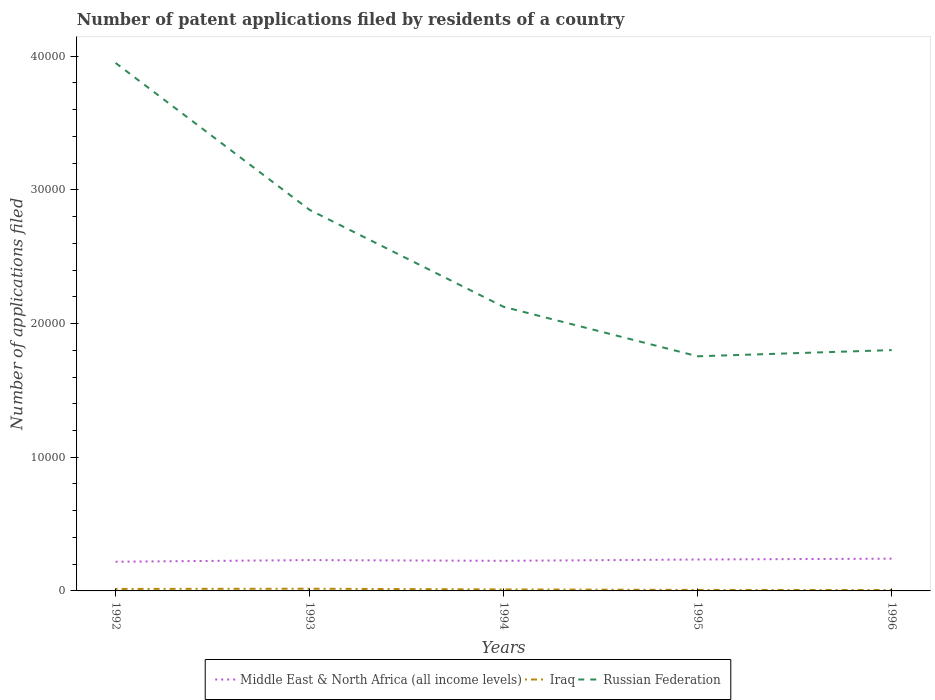How many different coloured lines are there?
Provide a succinct answer. 3. Does the line corresponding to Russian Federation intersect with the line corresponding to Middle East & North Africa (all income levels)?
Provide a short and direct response. No. Is the number of lines equal to the number of legend labels?
Your response must be concise. Yes. Across all years, what is the maximum number of applications filed in Russian Federation?
Offer a terse response. 1.76e+04. In which year was the number of applications filed in Russian Federation maximum?
Provide a short and direct response. 1995. What is the total number of applications filed in Russian Federation in the graph?
Provide a short and direct response. 1.82e+04. What is the difference between the highest and the second highest number of applications filed in Middle East & North Africa (all income levels)?
Keep it short and to the point. 230. Is the number of applications filed in Russian Federation strictly greater than the number of applications filed in Middle East & North Africa (all income levels) over the years?
Keep it short and to the point. No. Are the values on the major ticks of Y-axis written in scientific E-notation?
Provide a short and direct response. No. Does the graph contain grids?
Your response must be concise. No. What is the title of the graph?
Provide a succinct answer. Number of patent applications filed by residents of a country. Does "Bhutan" appear as one of the legend labels in the graph?
Your answer should be compact. No. What is the label or title of the X-axis?
Provide a succinct answer. Years. What is the label or title of the Y-axis?
Ensure brevity in your answer.  Number of applications filed. What is the Number of applications filed of Middle East & North Africa (all income levels) in 1992?
Keep it short and to the point. 2184. What is the Number of applications filed in Iraq in 1992?
Your response must be concise. 149. What is the Number of applications filed in Russian Federation in 1992?
Provide a short and direct response. 3.95e+04. What is the Number of applications filed of Middle East & North Africa (all income levels) in 1993?
Offer a very short reply. 2306. What is the Number of applications filed in Iraq in 1993?
Offer a terse response. 164. What is the Number of applications filed in Russian Federation in 1993?
Offer a very short reply. 2.85e+04. What is the Number of applications filed of Middle East & North Africa (all income levels) in 1994?
Your response must be concise. 2251. What is the Number of applications filed of Iraq in 1994?
Provide a short and direct response. 112. What is the Number of applications filed in Russian Federation in 1994?
Give a very brief answer. 2.12e+04. What is the Number of applications filed in Middle East & North Africa (all income levels) in 1995?
Your response must be concise. 2350. What is the Number of applications filed of Russian Federation in 1995?
Make the answer very short. 1.76e+04. What is the Number of applications filed of Middle East & North Africa (all income levels) in 1996?
Your answer should be very brief. 2414. What is the Number of applications filed in Russian Federation in 1996?
Offer a very short reply. 1.80e+04. Across all years, what is the maximum Number of applications filed of Middle East & North Africa (all income levels)?
Your answer should be compact. 2414. Across all years, what is the maximum Number of applications filed of Iraq?
Give a very brief answer. 164. Across all years, what is the maximum Number of applications filed of Russian Federation?
Keep it short and to the point. 3.95e+04. Across all years, what is the minimum Number of applications filed in Middle East & North Africa (all income levels)?
Make the answer very short. 2184. Across all years, what is the minimum Number of applications filed of Iraq?
Make the answer very short. 68. Across all years, what is the minimum Number of applications filed in Russian Federation?
Offer a terse response. 1.76e+04. What is the total Number of applications filed in Middle East & North Africa (all income levels) in the graph?
Offer a terse response. 1.15e+04. What is the total Number of applications filed in Iraq in the graph?
Your response must be concise. 569. What is the total Number of applications filed in Russian Federation in the graph?
Your answer should be compact. 1.25e+05. What is the difference between the Number of applications filed in Middle East & North Africa (all income levels) in 1992 and that in 1993?
Make the answer very short. -122. What is the difference between the Number of applications filed in Iraq in 1992 and that in 1993?
Your answer should be compact. -15. What is the difference between the Number of applications filed in Russian Federation in 1992 and that in 1993?
Your answer should be very brief. 1.10e+04. What is the difference between the Number of applications filed in Middle East & North Africa (all income levels) in 1992 and that in 1994?
Provide a succinct answer. -67. What is the difference between the Number of applications filed of Iraq in 1992 and that in 1994?
Your answer should be compact. 37. What is the difference between the Number of applications filed of Russian Federation in 1992 and that in 1994?
Your answer should be very brief. 1.82e+04. What is the difference between the Number of applications filed in Middle East & North Africa (all income levels) in 1992 and that in 1995?
Provide a succinct answer. -166. What is the difference between the Number of applications filed of Russian Federation in 1992 and that in 1995?
Offer a terse response. 2.19e+04. What is the difference between the Number of applications filed of Middle East & North Africa (all income levels) in 1992 and that in 1996?
Provide a succinct answer. -230. What is the difference between the Number of applications filed of Russian Federation in 1992 and that in 1996?
Provide a succinct answer. 2.15e+04. What is the difference between the Number of applications filed of Russian Federation in 1993 and that in 1994?
Give a very brief answer. 7253. What is the difference between the Number of applications filed of Middle East & North Africa (all income levels) in 1993 and that in 1995?
Keep it short and to the point. -44. What is the difference between the Number of applications filed in Iraq in 1993 and that in 1995?
Ensure brevity in your answer.  88. What is the difference between the Number of applications filed of Russian Federation in 1993 and that in 1995?
Your answer should be very brief. 1.10e+04. What is the difference between the Number of applications filed of Middle East & North Africa (all income levels) in 1993 and that in 1996?
Offer a terse response. -108. What is the difference between the Number of applications filed of Iraq in 1993 and that in 1996?
Provide a succinct answer. 96. What is the difference between the Number of applications filed of Russian Federation in 1993 and that in 1996?
Keep it short and to the point. 1.05e+04. What is the difference between the Number of applications filed of Middle East & North Africa (all income levels) in 1994 and that in 1995?
Provide a succinct answer. -99. What is the difference between the Number of applications filed in Iraq in 1994 and that in 1995?
Your answer should be very brief. 36. What is the difference between the Number of applications filed in Russian Federation in 1994 and that in 1995?
Your answer should be compact. 3699. What is the difference between the Number of applications filed of Middle East & North Africa (all income levels) in 1994 and that in 1996?
Ensure brevity in your answer.  -163. What is the difference between the Number of applications filed of Russian Federation in 1994 and that in 1996?
Offer a very short reply. 3236. What is the difference between the Number of applications filed of Middle East & North Africa (all income levels) in 1995 and that in 1996?
Make the answer very short. -64. What is the difference between the Number of applications filed of Iraq in 1995 and that in 1996?
Ensure brevity in your answer.  8. What is the difference between the Number of applications filed of Russian Federation in 1995 and that in 1996?
Make the answer very short. -463. What is the difference between the Number of applications filed in Middle East & North Africa (all income levels) in 1992 and the Number of applications filed in Iraq in 1993?
Provide a short and direct response. 2020. What is the difference between the Number of applications filed of Middle East & North Africa (all income levels) in 1992 and the Number of applications filed of Russian Federation in 1993?
Offer a terse response. -2.63e+04. What is the difference between the Number of applications filed in Iraq in 1992 and the Number of applications filed in Russian Federation in 1993?
Provide a short and direct response. -2.84e+04. What is the difference between the Number of applications filed in Middle East & North Africa (all income levels) in 1992 and the Number of applications filed in Iraq in 1994?
Offer a very short reply. 2072. What is the difference between the Number of applications filed in Middle East & North Africa (all income levels) in 1992 and the Number of applications filed in Russian Federation in 1994?
Your answer should be compact. -1.91e+04. What is the difference between the Number of applications filed of Iraq in 1992 and the Number of applications filed of Russian Federation in 1994?
Provide a succinct answer. -2.11e+04. What is the difference between the Number of applications filed of Middle East & North Africa (all income levels) in 1992 and the Number of applications filed of Iraq in 1995?
Your answer should be very brief. 2108. What is the difference between the Number of applications filed in Middle East & North Africa (all income levels) in 1992 and the Number of applications filed in Russian Federation in 1995?
Provide a short and direct response. -1.54e+04. What is the difference between the Number of applications filed of Iraq in 1992 and the Number of applications filed of Russian Federation in 1995?
Keep it short and to the point. -1.74e+04. What is the difference between the Number of applications filed in Middle East & North Africa (all income levels) in 1992 and the Number of applications filed in Iraq in 1996?
Your answer should be very brief. 2116. What is the difference between the Number of applications filed in Middle East & North Africa (all income levels) in 1992 and the Number of applications filed in Russian Federation in 1996?
Make the answer very short. -1.58e+04. What is the difference between the Number of applications filed of Iraq in 1992 and the Number of applications filed of Russian Federation in 1996?
Provide a short and direct response. -1.79e+04. What is the difference between the Number of applications filed of Middle East & North Africa (all income levels) in 1993 and the Number of applications filed of Iraq in 1994?
Ensure brevity in your answer.  2194. What is the difference between the Number of applications filed of Middle East & North Africa (all income levels) in 1993 and the Number of applications filed of Russian Federation in 1994?
Make the answer very short. -1.89e+04. What is the difference between the Number of applications filed of Iraq in 1993 and the Number of applications filed of Russian Federation in 1994?
Provide a short and direct response. -2.11e+04. What is the difference between the Number of applications filed in Middle East & North Africa (all income levels) in 1993 and the Number of applications filed in Iraq in 1995?
Make the answer very short. 2230. What is the difference between the Number of applications filed of Middle East & North Africa (all income levels) in 1993 and the Number of applications filed of Russian Federation in 1995?
Make the answer very short. -1.52e+04. What is the difference between the Number of applications filed in Iraq in 1993 and the Number of applications filed in Russian Federation in 1995?
Offer a terse response. -1.74e+04. What is the difference between the Number of applications filed of Middle East & North Africa (all income levels) in 1993 and the Number of applications filed of Iraq in 1996?
Offer a terse response. 2238. What is the difference between the Number of applications filed in Middle East & North Africa (all income levels) in 1993 and the Number of applications filed in Russian Federation in 1996?
Offer a very short reply. -1.57e+04. What is the difference between the Number of applications filed in Iraq in 1993 and the Number of applications filed in Russian Federation in 1996?
Provide a succinct answer. -1.78e+04. What is the difference between the Number of applications filed of Middle East & North Africa (all income levels) in 1994 and the Number of applications filed of Iraq in 1995?
Your response must be concise. 2175. What is the difference between the Number of applications filed of Middle East & North Africa (all income levels) in 1994 and the Number of applications filed of Russian Federation in 1995?
Offer a very short reply. -1.53e+04. What is the difference between the Number of applications filed of Iraq in 1994 and the Number of applications filed of Russian Federation in 1995?
Keep it short and to the point. -1.74e+04. What is the difference between the Number of applications filed in Middle East & North Africa (all income levels) in 1994 and the Number of applications filed in Iraq in 1996?
Ensure brevity in your answer.  2183. What is the difference between the Number of applications filed in Middle East & North Africa (all income levels) in 1994 and the Number of applications filed in Russian Federation in 1996?
Provide a succinct answer. -1.58e+04. What is the difference between the Number of applications filed in Iraq in 1994 and the Number of applications filed in Russian Federation in 1996?
Your response must be concise. -1.79e+04. What is the difference between the Number of applications filed of Middle East & North Africa (all income levels) in 1995 and the Number of applications filed of Iraq in 1996?
Provide a short and direct response. 2282. What is the difference between the Number of applications filed in Middle East & North Africa (all income levels) in 1995 and the Number of applications filed in Russian Federation in 1996?
Ensure brevity in your answer.  -1.57e+04. What is the difference between the Number of applications filed of Iraq in 1995 and the Number of applications filed of Russian Federation in 1996?
Offer a very short reply. -1.79e+04. What is the average Number of applications filed in Middle East & North Africa (all income levels) per year?
Provide a succinct answer. 2301. What is the average Number of applications filed in Iraq per year?
Your answer should be compact. 113.8. What is the average Number of applications filed of Russian Federation per year?
Make the answer very short. 2.50e+04. In the year 1992, what is the difference between the Number of applications filed in Middle East & North Africa (all income levels) and Number of applications filed in Iraq?
Give a very brief answer. 2035. In the year 1992, what is the difference between the Number of applications filed of Middle East & North Africa (all income levels) and Number of applications filed of Russian Federation?
Your answer should be compact. -3.73e+04. In the year 1992, what is the difference between the Number of applications filed of Iraq and Number of applications filed of Russian Federation?
Your answer should be compact. -3.93e+04. In the year 1993, what is the difference between the Number of applications filed of Middle East & North Africa (all income levels) and Number of applications filed of Iraq?
Give a very brief answer. 2142. In the year 1993, what is the difference between the Number of applications filed in Middle East & North Africa (all income levels) and Number of applications filed in Russian Federation?
Provide a succinct answer. -2.62e+04. In the year 1993, what is the difference between the Number of applications filed of Iraq and Number of applications filed of Russian Federation?
Your answer should be very brief. -2.83e+04. In the year 1994, what is the difference between the Number of applications filed of Middle East & North Africa (all income levels) and Number of applications filed of Iraq?
Your answer should be very brief. 2139. In the year 1994, what is the difference between the Number of applications filed of Middle East & North Africa (all income levels) and Number of applications filed of Russian Federation?
Make the answer very short. -1.90e+04. In the year 1994, what is the difference between the Number of applications filed of Iraq and Number of applications filed of Russian Federation?
Provide a short and direct response. -2.11e+04. In the year 1995, what is the difference between the Number of applications filed of Middle East & North Africa (all income levels) and Number of applications filed of Iraq?
Give a very brief answer. 2274. In the year 1995, what is the difference between the Number of applications filed of Middle East & North Africa (all income levels) and Number of applications filed of Russian Federation?
Offer a terse response. -1.52e+04. In the year 1995, what is the difference between the Number of applications filed in Iraq and Number of applications filed in Russian Federation?
Provide a succinct answer. -1.75e+04. In the year 1996, what is the difference between the Number of applications filed of Middle East & North Africa (all income levels) and Number of applications filed of Iraq?
Give a very brief answer. 2346. In the year 1996, what is the difference between the Number of applications filed in Middle East & North Africa (all income levels) and Number of applications filed in Russian Federation?
Your response must be concise. -1.56e+04. In the year 1996, what is the difference between the Number of applications filed in Iraq and Number of applications filed in Russian Federation?
Ensure brevity in your answer.  -1.79e+04. What is the ratio of the Number of applications filed of Middle East & North Africa (all income levels) in 1992 to that in 1993?
Offer a very short reply. 0.95. What is the ratio of the Number of applications filed in Iraq in 1992 to that in 1993?
Provide a short and direct response. 0.91. What is the ratio of the Number of applications filed in Russian Federation in 1992 to that in 1993?
Provide a short and direct response. 1.39. What is the ratio of the Number of applications filed of Middle East & North Africa (all income levels) in 1992 to that in 1994?
Offer a very short reply. 0.97. What is the ratio of the Number of applications filed in Iraq in 1992 to that in 1994?
Offer a terse response. 1.33. What is the ratio of the Number of applications filed of Russian Federation in 1992 to that in 1994?
Keep it short and to the point. 1.86. What is the ratio of the Number of applications filed in Middle East & North Africa (all income levels) in 1992 to that in 1995?
Provide a succinct answer. 0.93. What is the ratio of the Number of applications filed in Iraq in 1992 to that in 1995?
Offer a terse response. 1.96. What is the ratio of the Number of applications filed in Russian Federation in 1992 to that in 1995?
Offer a terse response. 2.25. What is the ratio of the Number of applications filed in Middle East & North Africa (all income levels) in 1992 to that in 1996?
Provide a succinct answer. 0.9. What is the ratio of the Number of applications filed of Iraq in 1992 to that in 1996?
Provide a short and direct response. 2.19. What is the ratio of the Number of applications filed of Russian Federation in 1992 to that in 1996?
Make the answer very short. 2.19. What is the ratio of the Number of applications filed in Middle East & North Africa (all income levels) in 1993 to that in 1994?
Ensure brevity in your answer.  1.02. What is the ratio of the Number of applications filed of Iraq in 1993 to that in 1994?
Offer a terse response. 1.46. What is the ratio of the Number of applications filed of Russian Federation in 1993 to that in 1994?
Your response must be concise. 1.34. What is the ratio of the Number of applications filed in Middle East & North Africa (all income levels) in 1993 to that in 1995?
Your response must be concise. 0.98. What is the ratio of the Number of applications filed of Iraq in 1993 to that in 1995?
Provide a succinct answer. 2.16. What is the ratio of the Number of applications filed in Russian Federation in 1993 to that in 1995?
Give a very brief answer. 1.62. What is the ratio of the Number of applications filed of Middle East & North Africa (all income levels) in 1993 to that in 1996?
Keep it short and to the point. 0.96. What is the ratio of the Number of applications filed in Iraq in 1993 to that in 1996?
Make the answer very short. 2.41. What is the ratio of the Number of applications filed in Russian Federation in 1993 to that in 1996?
Give a very brief answer. 1.58. What is the ratio of the Number of applications filed in Middle East & North Africa (all income levels) in 1994 to that in 1995?
Offer a very short reply. 0.96. What is the ratio of the Number of applications filed of Iraq in 1994 to that in 1995?
Ensure brevity in your answer.  1.47. What is the ratio of the Number of applications filed of Russian Federation in 1994 to that in 1995?
Your answer should be compact. 1.21. What is the ratio of the Number of applications filed in Middle East & North Africa (all income levels) in 1994 to that in 1996?
Provide a succinct answer. 0.93. What is the ratio of the Number of applications filed of Iraq in 1994 to that in 1996?
Ensure brevity in your answer.  1.65. What is the ratio of the Number of applications filed of Russian Federation in 1994 to that in 1996?
Your answer should be very brief. 1.18. What is the ratio of the Number of applications filed of Middle East & North Africa (all income levels) in 1995 to that in 1996?
Your response must be concise. 0.97. What is the ratio of the Number of applications filed in Iraq in 1995 to that in 1996?
Provide a short and direct response. 1.12. What is the ratio of the Number of applications filed in Russian Federation in 1995 to that in 1996?
Keep it short and to the point. 0.97. What is the difference between the highest and the second highest Number of applications filed in Middle East & North Africa (all income levels)?
Ensure brevity in your answer.  64. What is the difference between the highest and the second highest Number of applications filed of Iraq?
Keep it short and to the point. 15. What is the difference between the highest and the second highest Number of applications filed of Russian Federation?
Ensure brevity in your answer.  1.10e+04. What is the difference between the highest and the lowest Number of applications filed of Middle East & North Africa (all income levels)?
Your answer should be compact. 230. What is the difference between the highest and the lowest Number of applications filed in Iraq?
Make the answer very short. 96. What is the difference between the highest and the lowest Number of applications filed in Russian Federation?
Ensure brevity in your answer.  2.19e+04. 